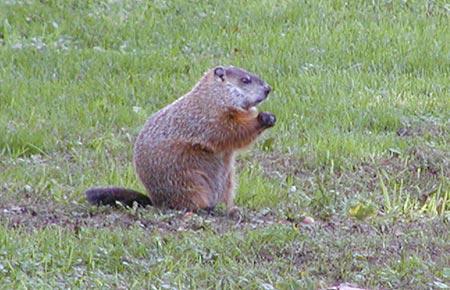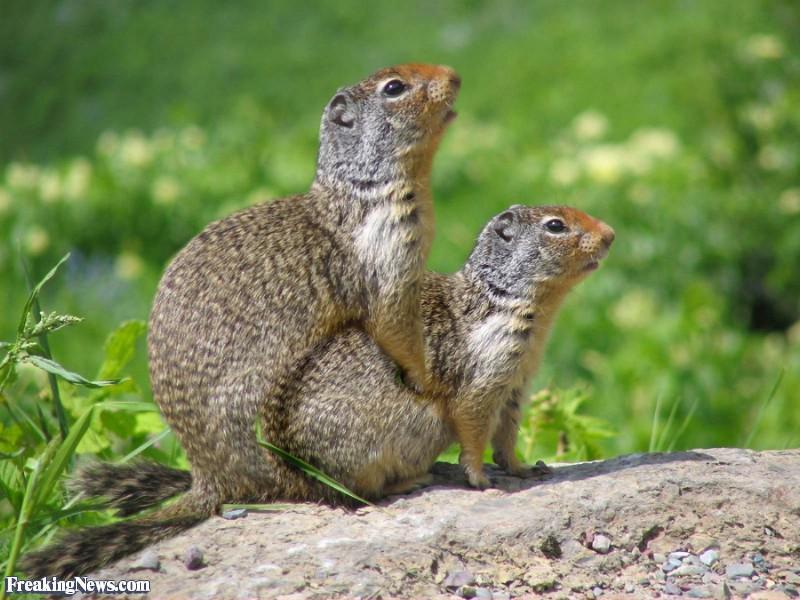The first image is the image on the left, the second image is the image on the right. Considering the images on both sides, is "There are only two animals and at least one appears to be eating something." valid? Answer yes or no. No. 